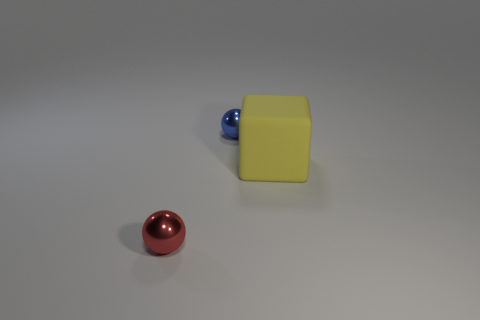What is the texture of the yellow object, and how does it compare to the surfaces of the other objects in the image? The yellow object has a matte texture, providing a stark contrast to the glossy finishes of the small blue and metallic red spheres. The smoothness of the spheres reflects light directly, while the yellow cube diffuses the light due to its non-reflective surface. 